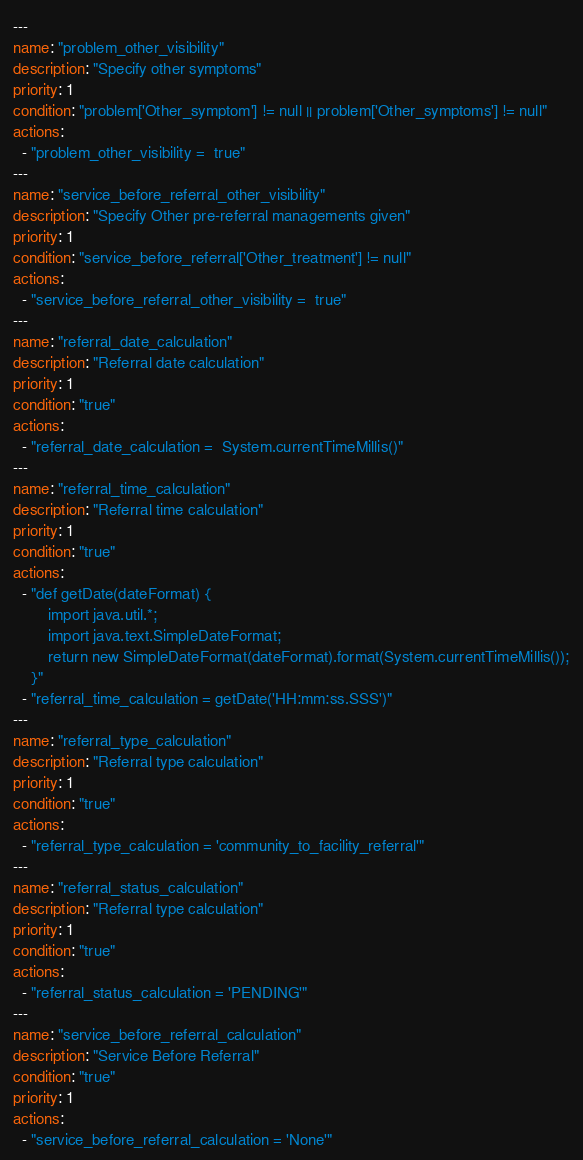<code> <loc_0><loc_0><loc_500><loc_500><_YAML_>---
name: "problem_other_visibility"
description: "Specify other symptoms"
priority: 1
condition: "problem['Other_symptom'] != null || problem['Other_symptoms'] != null"
actions:
  - "problem_other_visibility =  true"
---
name: "service_before_referral_other_visibility"
description: "Specify Other pre-referral managements given"
priority: 1
condition: "service_before_referral['Other_treatment'] != null"
actions:
  - "service_before_referral_other_visibility =  true"
---
name: "referral_date_calculation"
description: "Referral date calculation"
priority: 1
condition: "true"
actions:
  - "referral_date_calculation =  System.currentTimeMillis()"
---
name: "referral_time_calculation"
description: "Referral time calculation"
priority: 1
condition: "true"
actions:
  - "def getDate(dateFormat) {
        import java.util.*;
        import java.text.SimpleDateFormat;
        return new SimpleDateFormat(dateFormat).format(System.currentTimeMillis());
    }"
  - "referral_time_calculation = getDate('HH:mm:ss.SSS')"
---
name: "referral_type_calculation"
description: "Referral type calculation"
priority: 1
condition: "true"
actions:
  - "referral_type_calculation = 'community_to_facility_referral'"
---
name: "referral_status_calculation"
description: "Referral type calculation"
priority: 1
condition: "true"
actions:
  - "referral_status_calculation = 'PENDING'"
---
name: "service_before_referral_calculation"
description: "Service Before Referral"
condition: "true"
priority: 1
actions:
  - "service_before_referral_calculation = 'None'"</code> 